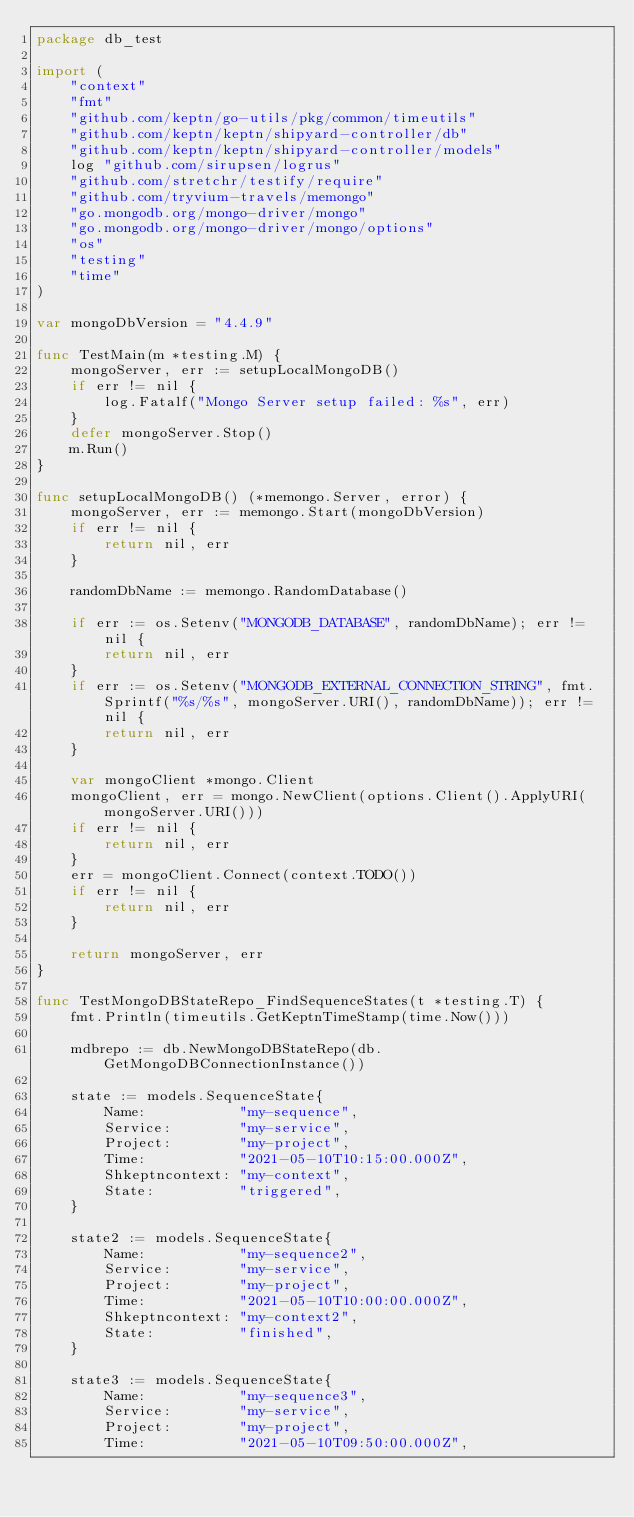<code> <loc_0><loc_0><loc_500><loc_500><_Go_>package db_test

import (
	"context"
	"fmt"
	"github.com/keptn/go-utils/pkg/common/timeutils"
	"github.com/keptn/keptn/shipyard-controller/db"
	"github.com/keptn/keptn/shipyard-controller/models"
	log "github.com/sirupsen/logrus"
	"github.com/stretchr/testify/require"
	"github.com/tryvium-travels/memongo"
	"go.mongodb.org/mongo-driver/mongo"
	"go.mongodb.org/mongo-driver/mongo/options"
	"os"
	"testing"
	"time"
)

var mongoDbVersion = "4.4.9"

func TestMain(m *testing.M) {
	mongoServer, err := setupLocalMongoDB()
	if err != nil {
		log.Fatalf("Mongo Server setup failed: %s", err)
	}
	defer mongoServer.Stop()
	m.Run()
}

func setupLocalMongoDB() (*memongo.Server, error) {
	mongoServer, err := memongo.Start(mongoDbVersion)
	if err != nil {
		return nil, err
	}

	randomDbName := memongo.RandomDatabase()

	if err := os.Setenv("MONGODB_DATABASE", randomDbName); err != nil {
		return nil, err
	}
	if err := os.Setenv("MONGODB_EXTERNAL_CONNECTION_STRING", fmt.Sprintf("%s/%s", mongoServer.URI(), randomDbName)); err != nil {
		return nil, err
	}

	var mongoClient *mongo.Client
	mongoClient, err = mongo.NewClient(options.Client().ApplyURI(mongoServer.URI()))
	if err != nil {
		return nil, err
	}
	err = mongoClient.Connect(context.TODO())
	if err != nil {
		return nil, err
	}

	return mongoServer, err
}

func TestMongoDBStateRepo_FindSequenceStates(t *testing.T) {
	fmt.Println(timeutils.GetKeptnTimeStamp(time.Now()))

	mdbrepo := db.NewMongoDBStateRepo(db.GetMongoDBConnectionInstance())

	state := models.SequenceState{
		Name:           "my-sequence",
		Service:        "my-service",
		Project:        "my-project",
		Time:           "2021-05-10T10:15:00.000Z",
		Shkeptncontext: "my-context",
		State:          "triggered",
	}

	state2 := models.SequenceState{
		Name:           "my-sequence2",
		Service:        "my-service",
		Project:        "my-project",
		Time:           "2021-05-10T10:00:00.000Z",
		Shkeptncontext: "my-context2",
		State:          "finished",
	}

	state3 := models.SequenceState{
		Name:           "my-sequence3",
		Service:        "my-service",
		Project:        "my-project",
		Time:           "2021-05-10T09:50:00.000Z",</code> 